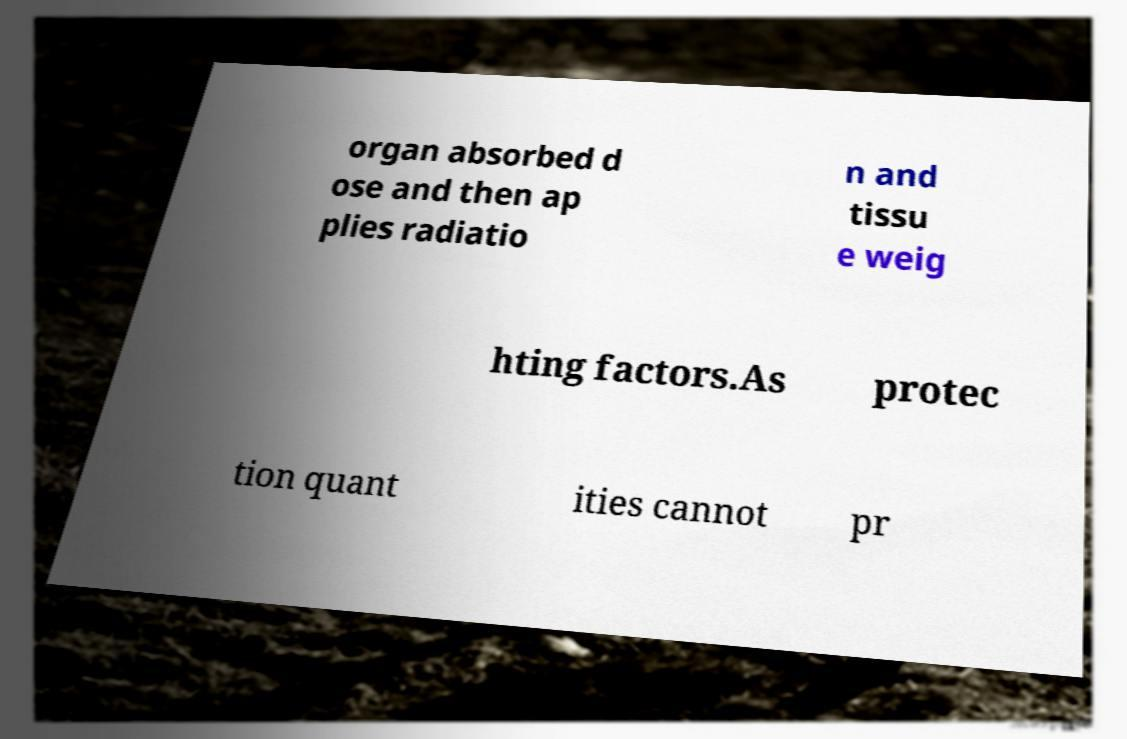I need the written content from this picture converted into text. Can you do that? organ absorbed d ose and then ap plies radiatio n and tissu e weig hting factors.As protec tion quant ities cannot pr 